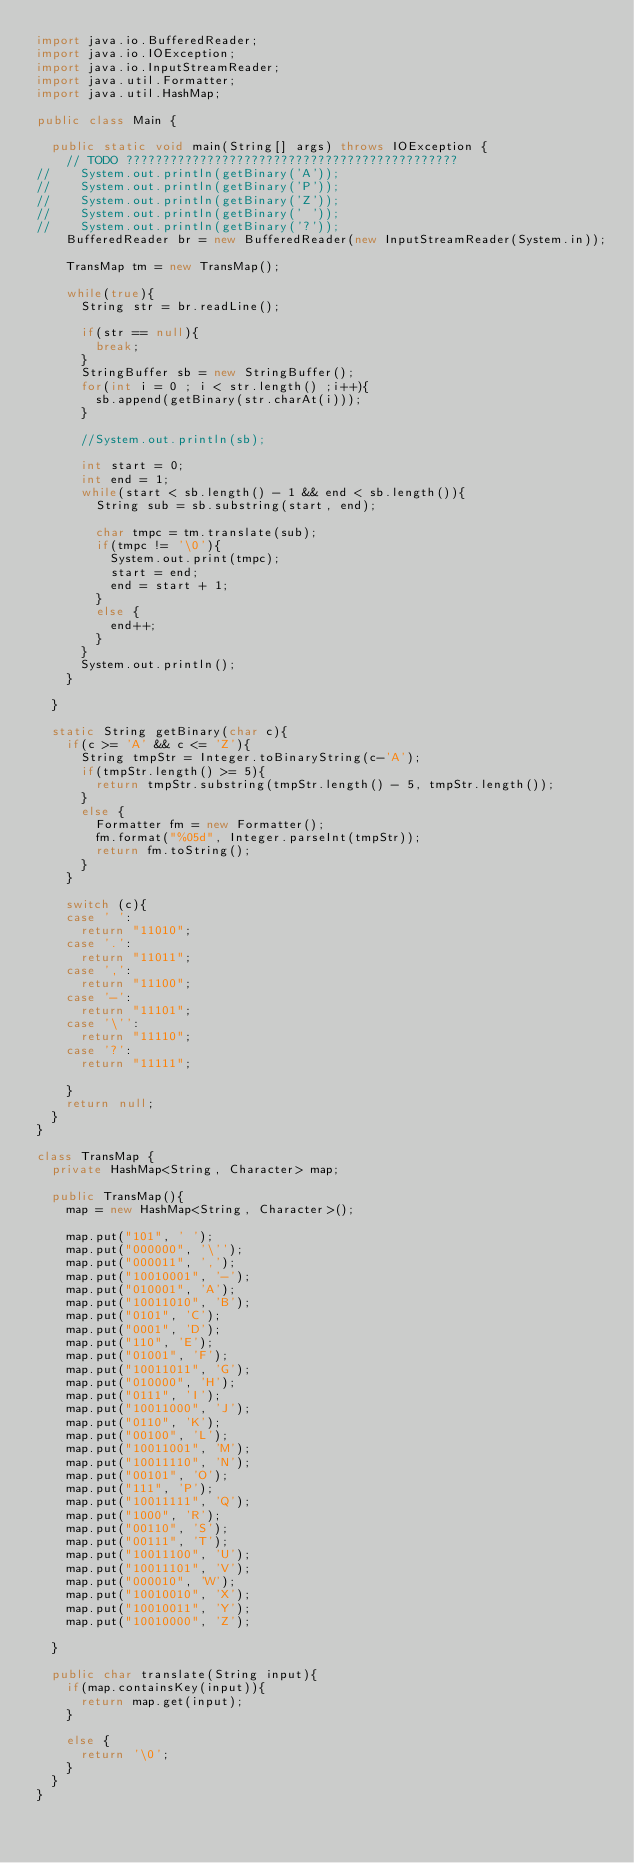<code> <loc_0><loc_0><loc_500><loc_500><_Java_>import java.io.BufferedReader;
import java.io.IOException;
import java.io.InputStreamReader;
import java.util.Formatter;
import java.util.HashMap;

public class Main {

	public static void main(String[] args) throws IOException {
		// TODO ?????????????????????????????????????????????
//		System.out.println(getBinary('A'));
//		System.out.println(getBinary('P'));
//		System.out.println(getBinary('Z'));
//		System.out.println(getBinary(' '));
//		System.out.println(getBinary('?'));
		BufferedReader br = new BufferedReader(new InputStreamReader(System.in));

		TransMap tm = new TransMap();
		
		while(true){
			String str = br.readLine();

			if(str == null){
				break;
			}
			StringBuffer sb = new StringBuffer();
			for(int i = 0 ; i < str.length() ;i++){
				sb.append(getBinary(str.charAt(i)));
			}
			
			//System.out.println(sb);
			
			int start = 0;
			int end = 1;
			while(start < sb.length() - 1 && end < sb.length()){
				String sub = sb.substring(start, end);
				
				char tmpc = tm.translate(sub);
				if(tmpc != '\0'){
					System.out.print(tmpc);
					start = end;
					end = start + 1;
				}
				else {
					end++;
				}
			}
			System.out.println();
		}

	}

	static String getBinary(char c){
		if(c >= 'A' && c <= 'Z'){
			String tmpStr = Integer.toBinaryString(c-'A');
			if(tmpStr.length() >= 5){
				return tmpStr.substring(tmpStr.length() - 5, tmpStr.length());
			}
			else {
				Formatter fm = new Formatter();
				fm.format("%05d", Integer.parseInt(tmpStr));
				return fm.toString();
			}
		}
		
		switch (c){
		case ' ':
			return "11010";
		case '.':
			return "11011";
		case ',':
			return "11100";
		case '-':
			return "11101";
		case '\'':
			return "11110";
		case '?':
			return "11111";
			
		}
		return null;
	}
}

class TransMap {
	private HashMap<String, Character> map;
	
	public TransMap(){
		map = new HashMap<String, Character>();
		
		map.put("101", ' ');
		map.put("000000", '\'');
		map.put("000011", ',');
		map.put("10010001", '-');
		map.put("010001", 'A');
		map.put("10011010", 'B');
		map.put("0101", 'C');
		map.put("0001", 'D');
		map.put("110", 'E');
		map.put("01001", 'F');
		map.put("10011011", 'G');
		map.put("010000", 'H');
		map.put("0111", 'I');
		map.put("10011000", 'J');
		map.put("0110", 'K');
		map.put("00100", 'L');
		map.put("10011001", 'M');
		map.put("10011110", 'N');
		map.put("00101", 'O');
		map.put("111", 'P');
		map.put("10011111", 'Q');
		map.put("1000", 'R');
		map.put("00110", 'S');
		map.put("00111", 'T');
		map.put("10011100", 'U');
		map.put("10011101", 'V');
		map.put("000010", 'W');
		map.put("10010010", 'X');
		map.put("10010011", 'Y');
		map.put("10010000", 'Z');

	}
	
	public char translate(String input){
		if(map.containsKey(input)){
			return map.get(input);
		}
		
		else {
			return '\0';
		}
	}
}</code> 